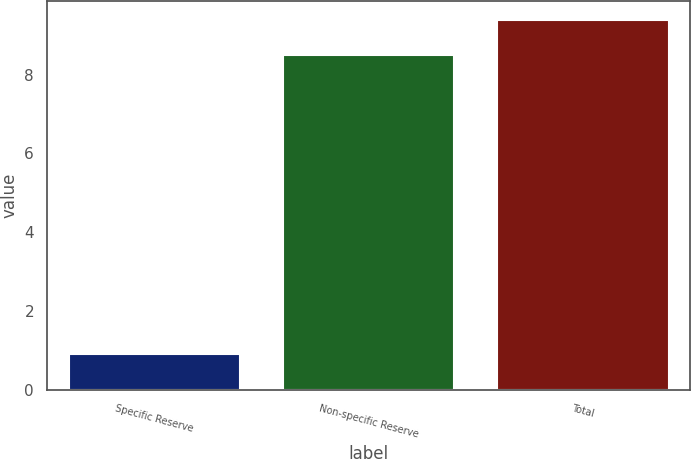Convert chart to OTSL. <chart><loc_0><loc_0><loc_500><loc_500><bar_chart><fcel>Specific Reserve<fcel>Non-specific Reserve<fcel>Total<nl><fcel>0.9<fcel>8.5<fcel>9.4<nl></chart> 